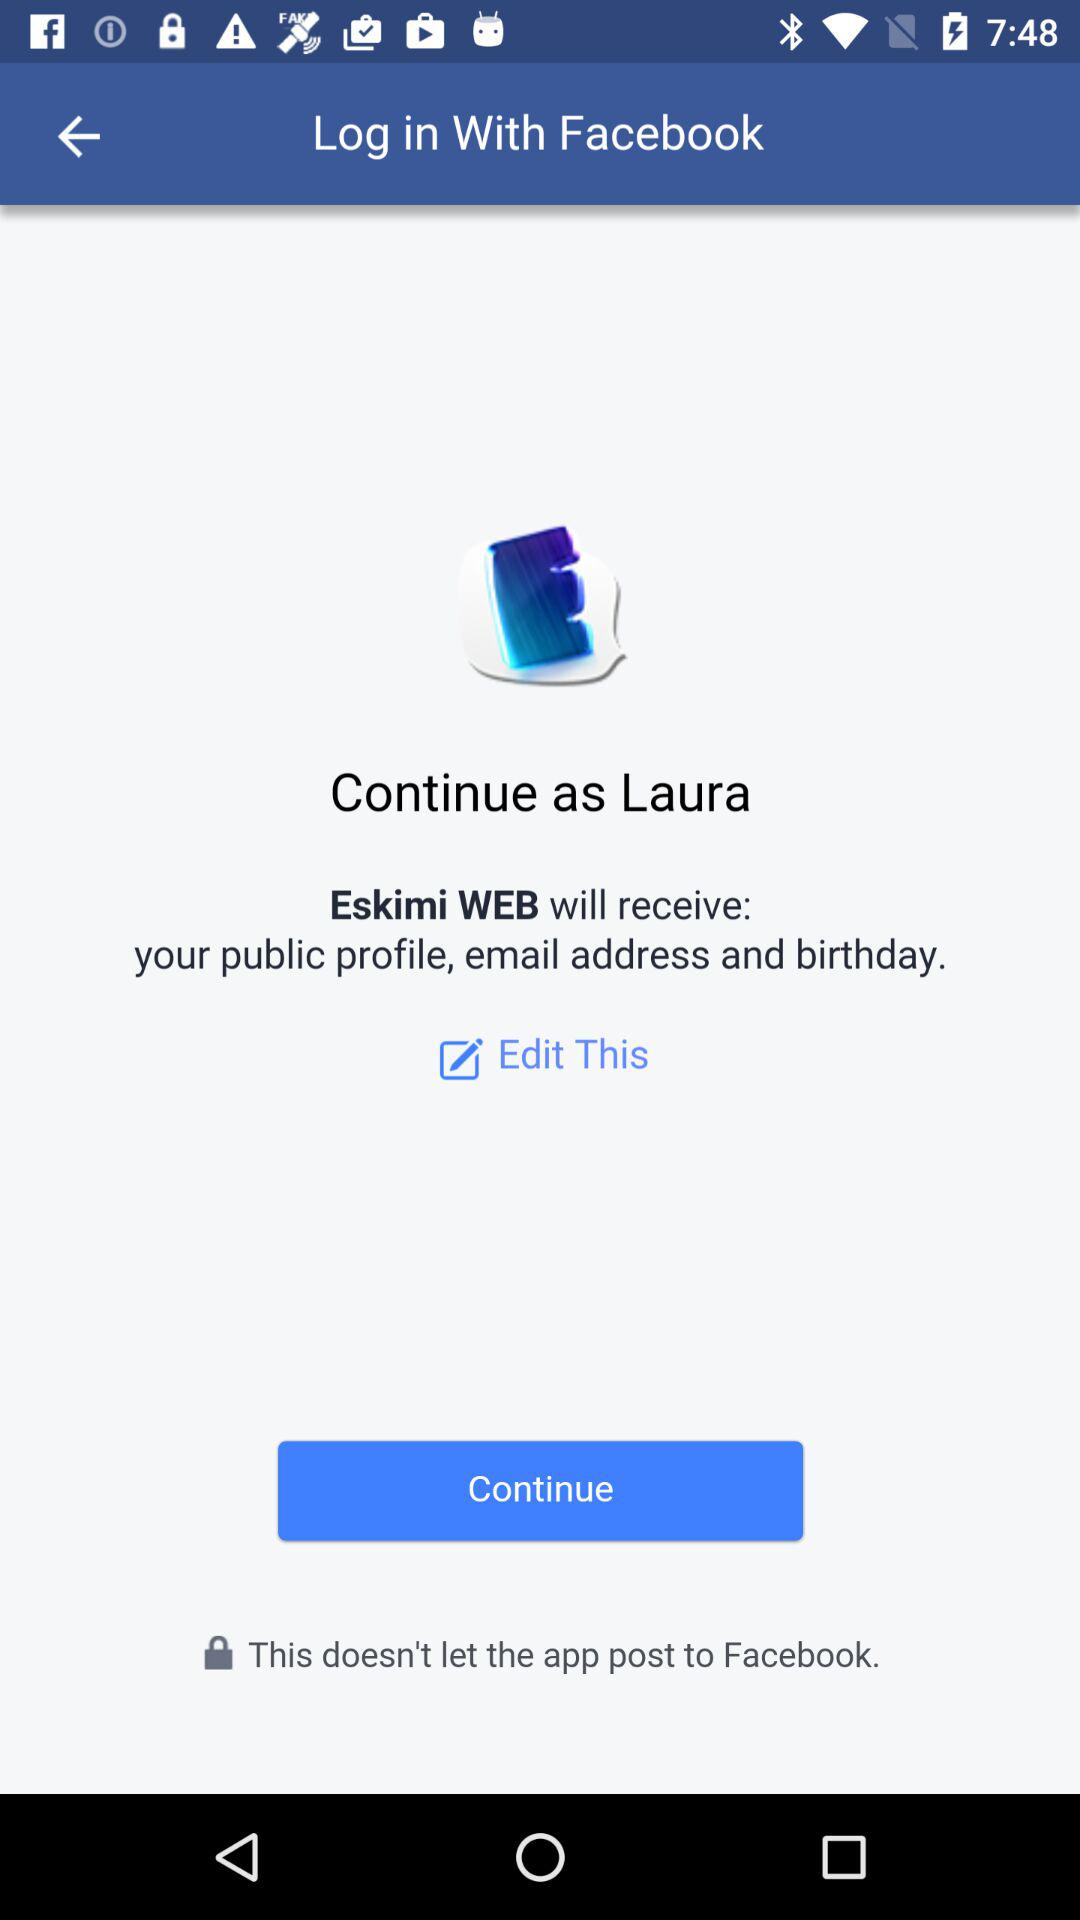What is the user name? The user name is Laura. 